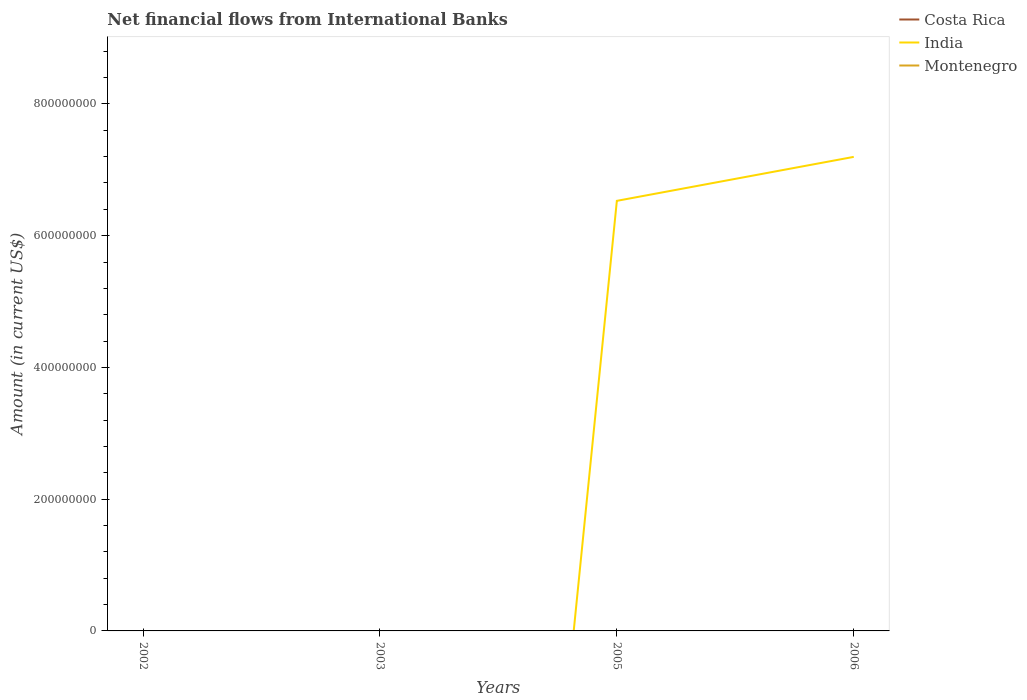Does the line corresponding to India intersect with the line corresponding to Costa Rica?
Make the answer very short. Yes. Across all years, what is the maximum net financial aid flows in India?
Offer a terse response. 0. What is the total net financial aid flows in India in the graph?
Offer a very short reply. -6.67e+07. What is the difference between the highest and the second highest net financial aid flows in India?
Give a very brief answer. 7.20e+08. How many years are there in the graph?
Give a very brief answer. 4. Where does the legend appear in the graph?
Your response must be concise. Top right. How many legend labels are there?
Provide a short and direct response. 3. What is the title of the graph?
Your answer should be very brief. Net financial flows from International Banks. What is the label or title of the Y-axis?
Your answer should be very brief. Amount (in current US$). What is the Amount (in current US$) in India in 2002?
Provide a succinct answer. 0. What is the Amount (in current US$) of Montenegro in 2003?
Your answer should be very brief. 0. What is the Amount (in current US$) in Costa Rica in 2005?
Your answer should be compact. 0. What is the Amount (in current US$) of India in 2005?
Give a very brief answer. 6.53e+08. What is the Amount (in current US$) of India in 2006?
Give a very brief answer. 7.20e+08. What is the Amount (in current US$) of Montenegro in 2006?
Provide a short and direct response. 0. Across all years, what is the maximum Amount (in current US$) in India?
Ensure brevity in your answer.  7.20e+08. Across all years, what is the minimum Amount (in current US$) in India?
Ensure brevity in your answer.  0. What is the total Amount (in current US$) in Costa Rica in the graph?
Keep it short and to the point. 0. What is the total Amount (in current US$) in India in the graph?
Ensure brevity in your answer.  1.37e+09. What is the total Amount (in current US$) in Montenegro in the graph?
Give a very brief answer. 0. What is the difference between the Amount (in current US$) in India in 2005 and that in 2006?
Provide a short and direct response. -6.67e+07. What is the average Amount (in current US$) of India per year?
Provide a short and direct response. 3.43e+08. What is the ratio of the Amount (in current US$) in India in 2005 to that in 2006?
Ensure brevity in your answer.  0.91. What is the difference between the highest and the lowest Amount (in current US$) of India?
Your answer should be compact. 7.20e+08. 